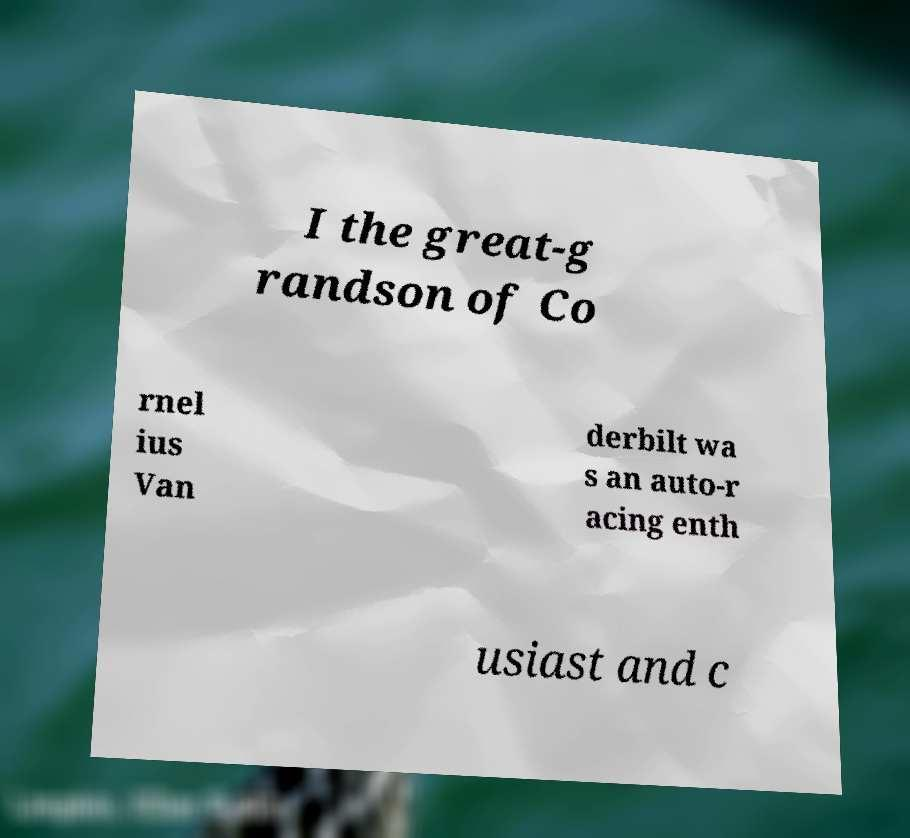Could you assist in decoding the text presented in this image and type it out clearly? I the great-g randson of Co rnel ius Van derbilt wa s an auto-r acing enth usiast and c 